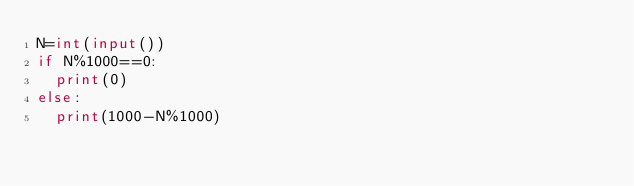<code> <loc_0><loc_0><loc_500><loc_500><_Python_>N=int(input())
if N%1000==0:
  print(0)
else:
  print(1000-N%1000)</code> 